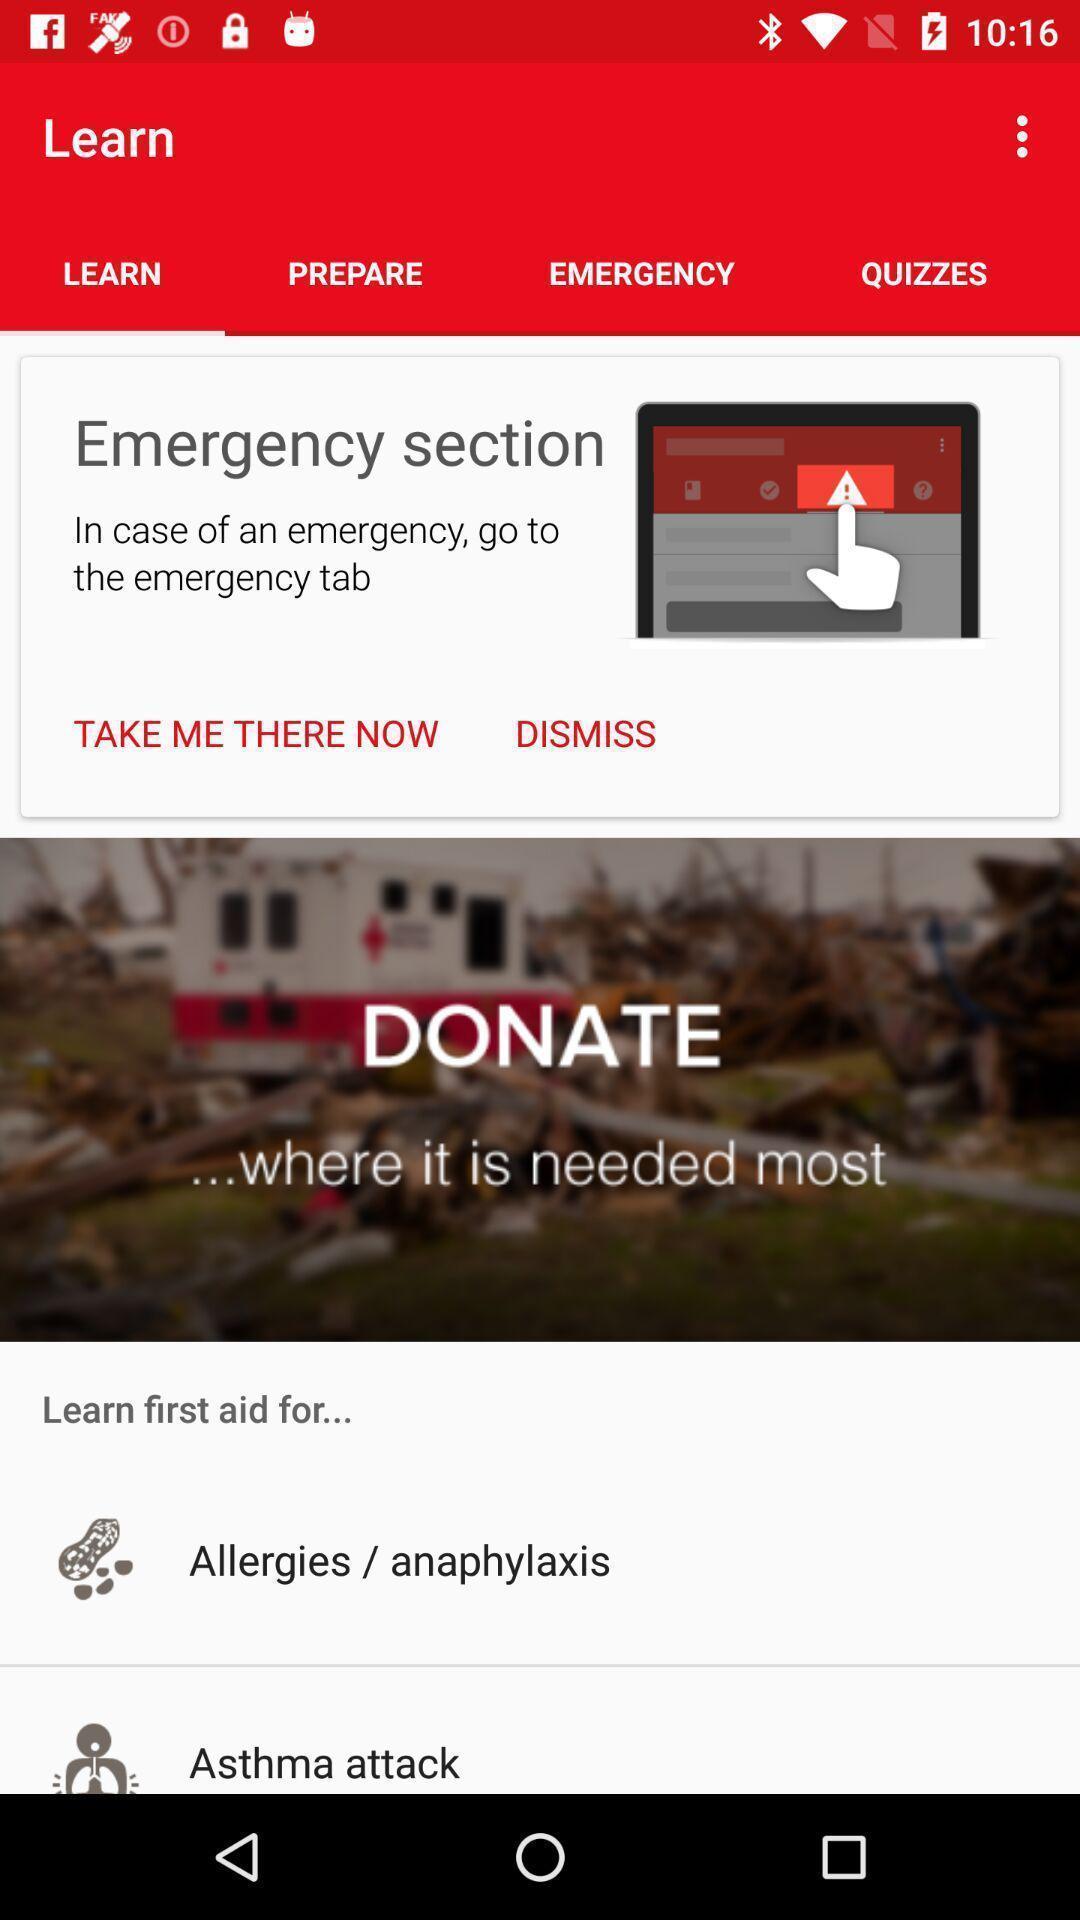Summarize the information in this screenshot. Page displaying some features. 